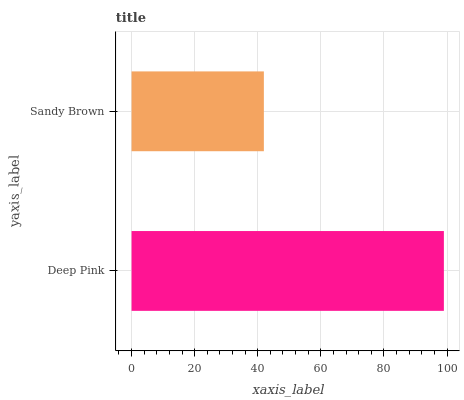Is Sandy Brown the minimum?
Answer yes or no. Yes. Is Deep Pink the maximum?
Answer yes or no. Yes. Is Sandy Brown the maximum?
Answer yes or no. No. Is Deep Pink greater than Sandy Brown?
Answer yes or no. Yes. Is Sandy Brown less than Deep Pink?
Answer yes or no. Yes. Is Sandy Brown greater than Deep Pink?
Answer yes or no. No. Is Deep Pink less than Sandy Brown?
Answer yes or no. No. Is Deep Pink the high median?
Answer yes or no. Yes. Is Sandy Brown the low median?
Answer yes or no. Yes. Is Sandy Brown the high median?
Answer yes or no. No. Is Deep Pink the low median?
Answer yes or no. No. 